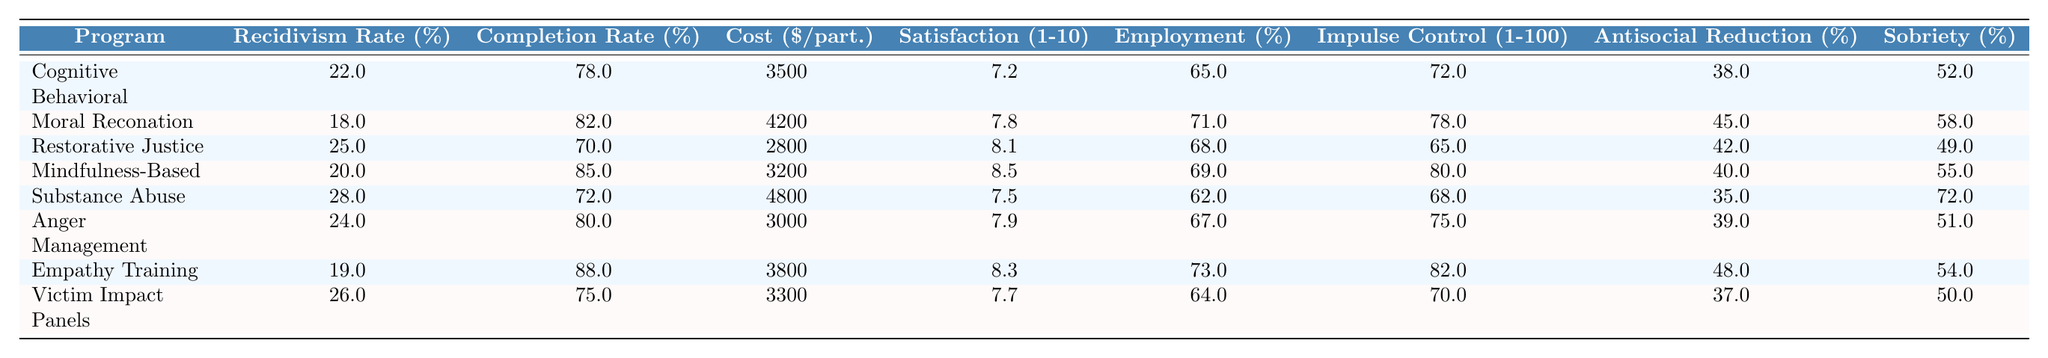What is the completion rate for Empathy Training? The table shows that the completion rate for Empathy Training is 88%.
Answer: 88% Which program has the highest participant satisfaction score? By examining the satisfaction column, Mindfulness-Based Stress Reduction has the highest score of 8.5.
Answer: Mindfulness-Based Stress Reduction Is the employment rate post-program higher for Anger Management or Cognitive Behavioral Therapy? The employment rate for Anger Management is 67%, while it is 65% for Cognitive Behavioral Therapy. Therefore, Anger Management has a higher employment rate.
Answer: Yes What is the average recidivism rate for all programs? To find the average, sum all recidivism rates (22 + 18 + 25 + 20 + 28 + 24 + 19 + 26) = 192, then divide by 8 (the number of programs), resulting in an average of 24%.
Answer: 24% Which rehabilitation program has the lowest cost-effectiveness? The cost-effectiveness measured by cost per participant is lowest for Restorative Justice Programs at $2800.
Answer: Restorative Justice Programs Is the reduction in antisocial behavior for Moral Reconation Therapy greater than the average for all programs? The reduction for Moral Reconation Therapy is 45%, while the average reduction across all programs is (38 + 45 + 42 + 40 + 35 + 39 + 48 + 37)/8 = 40.5%. Since 45% is greater than 40.5%, the answer is yes.
Answer: Yes What is the difference in long-term sobriety rates between Substance Abuse Treatment and Cognitive Behavioral Therapy? Compare the long-term sobriety rate for both: Substance Abuse Treatment is 72% and Cognitive Behavioral Therapy is 52%. The difference is 72 - 52 = 20%.
Answer: 20% Which program shows the greatest improvement in impulse control? The impulse control score for Empathy Training is 82, which is the highest among all programs.
Answer: Empathy Training How does the completion rate of Restorative Justice Programs compare to the program with the highest completion rate? Restorative Justice Programs have a completion rate of 70%, while the highest is Empathy Training at 88%. The difference is 88 - 70 = 18%.
Answer: 18% Are participants more satisfied with Mindfulness-Based Stress Reduction than with Substance Abuse Treatment? Mindfulness-Based Stress Reduction has a satisfaction score of 8.5, whereas Substance Abuse Treatment has a score of 7.5, making participants more satisfied with Mindfulness-Based Stress Reduction.
Answer: Yes 